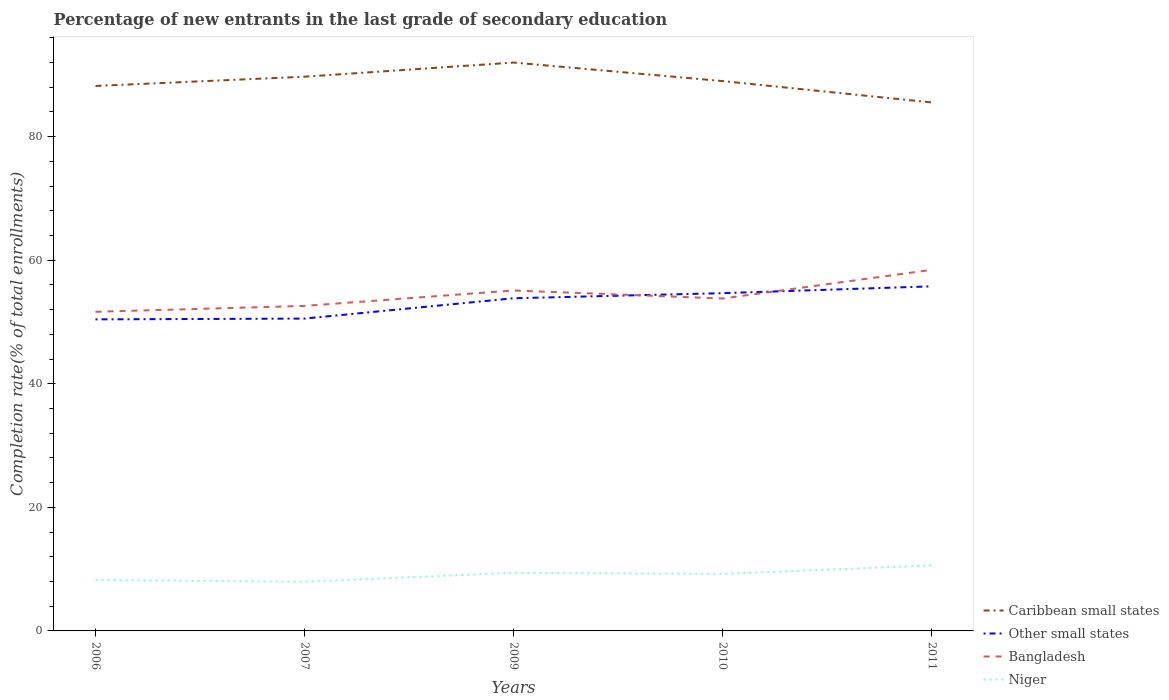Does the line corresponding to Niger intersect with the line corresponding to Caribbean small states?
Offer a very short reply. No. Across all years, what is the maximum percentage of new entrants in Other small states?
Make the answer very short. 50.43. In which year was the percentage of new entrants in Bangladesh maximum?
Provide a short and direct response. 2006. What is the total percentage of new entrants in Bangladesh in the graph?
Offer a very short reply. -4.64. What is the difference between the highest and the second highest percentage of new entrants in Bangladesh?
Offer a very short reply. 6.79. How many lines are there?
Give a very brief answer. 4. What is the difference between two consecutive major ticks on the Y-axis?
Your response must be concise. 20. Does the graph contain any zero values?
Give a very brief answer. No. How many legend labels are there?
Make the answer very short. 4. How are the legend labels stacked?
Your response must be concise. Vertical. What is the title of the graph?
Provide a succinct answer. Percentage of new entrants in the last grade of secondary education. What is the label or title of the Y-axis?
Your answer should be very brief. Completion rate(% of total enrollments). What is the Completion rate(% of total enrollments) in Caribbean small states in 2006?
Keep it short and to the point. 88.21. What is the Completion rate(% of total enrollments) of Other small states in 2006?
Offer a terse response. 50.43. What is the Completion rate(% of total enrollments) of Bangladesh in 2006?
Keep it short and to the point. 51.66. What is the Completion rate(% of total enrollments) of Niger in 2006?
Your answer should be compact. 8.24. What is the Completion rate(% of total enrollments) of Caribbean small states in 2007?
Your answer should be very brief. 89.71. What is the Completion rate(% of total enrollments) of Other small states in 2007?
Offer a terse response. 50.56. What is the Completion rate(% of total enrollments) in Bangladesh in 2007?
Your answer should be compact. 52.61. What is the Completion rate(% of total enrollments) in Niger in 2007?
Keep it short and to the point. 7.96. What is the Completion rate(% of total enrollments) in Caribbean small states in 2009?
Ensure brevity in your answer.  92. What is the Completion rate(% of total enrollments) in Other small states in 2009?
Your response must be concise. 53.85. What is the Completion rate(% of total enrollments) of Bangladesh in 2009?
Your response must be concise. 55.11. What is the Completion rate(% of total enrollments) in Niger in 2009?
Provide a short and direct response. 9.4. What is the Completion rate(% of total enrollments) in Caribbean small states in 2010?
Give a very brief answer. 89. What is the Completion rate(% of total enrollments) of Other small states in 2010?
Your answer should be compact. 54.67. What is the Completion rate(% of total enrollments) of Bangladesh in 2010?
Your answer should be very brief. 53.81. What is the Completion rate(% of total enrollments) of Niger in 2010?
Make the answer very short. 9.23. What is the Completion rate(% of total enrollments) of Caribbean small states in 2011?
Your answer should be very brief. 85.54. What is the Completion rate(% of total enrollments) in Other small states in 2011?
Offer a very short reply. 55.78. What is the Completion rate(% of total enrollments) of Bangladesh in 2011?
Provide a short and direct response. 58.45. What is the Completion rate(% of total enrollments) of Niger in 2011?
Make the answer very short. 10.6. Across all years, what is the maximum Completion rate(% of total enrollments) of Caribbean small states?
Your answer should be compact. 92. Across all years, what is the maximum Completion rate(% of total enrollments) of Other small states?
Your answer should be very brief. 55.78. Across all years, what is the maximum Completion rate(% of total enrollments) of Bangladesh?
Keep it short and to the point. 58.45. Across all years, what is the maximum Completion rate(% of total enrollments) of Niger?
Offer a very short reply. 10.6. Across all years, what is the minimum Completion rate(% of total enrollments) of Caribbean small states?
Offer a terse response. 85.54. Across all years, what is the minimum Completion rate(% of total enrollments) of Other small states?
Your answer should be very brief. 50.43. Across all years, what is the minimum Completion rate(% of total enrollments) in Bangladesh?
Provide a succinct answer. 51.66. Across all years, what is the minimum Completion rate(% of total enrollments) in Niger?
Your answer should be compact. 7.96. What is the total Completion rate(% of total enrollments) in Caribbean small states in the graph?
Ensure brevity in your answer.  444.46. What is the total Completion rate(% of total enrollments) in Other small states in the graph?
Provide a succinct answer. 265.28. What is the total Completion rate(% of total enrollments) in Bangladesh in the graph?
Make the answer very short. 271.63. What is the total Completion rate(% of total enrollments) in Niger in the graph?
Your response must be concise. 45.43. What is the difference between the Completion rate(% of total enrollments) in Caribbean small states in 2006 and that in 2007?
Offer a terse response. -1.5. What is the difference between the Completion rate(% of total enrollments) in Other small states in 2006 and that in 2007?
Ensure brevity in your answer.  -0.13. What is the difference between the Completion rate(% of total enrollments) of Bangladesh in 2006 and that in 2007?
Keep it short and to the point. -0.95. What is the difference between the Completion rate(% of total enrollments) in Niger in 2006 and that in 2007?
Provide a short and direct response. 0.28. What is the difference between the Completion rate(% of total enrollments) of Caribbean small states in 2006 and that in 2009?
Provide a short and direct response. -3.79. What is the difference between the Completion rate(% of total enrollments) in Other small states in 2006 and that in 2009?
Make the answer very short. -3.42. What is the difference between the Completion rate(% of total enrollments) of Bangladesh in 2006 and that in 2009?
Make the answer very short. -3.45. What is the difference between the Completion rate(% of total enrollments) in Niger in 2006 and that in 2009?
Your answer should be compact. -1.17. What is the difference between the Completion rate(% of total enrollments) in Caribbean small states in 2006 and that in 2010?
Offer a very short reply. -0.79. What is the difference between the Completion rate(% of total enrollments) of Other small states in 2006 and that in 2010?
Your answer should be compact. -4.24. What is the difference between the Completion rate(% of total enrollments) of Bangladesh in 2006 and that in 2010?
Give a very brief answer. -2.15. What is the difference between the Completion rate(% of total enrollments) of Niger in 2006 and that in 2010?
Make the answer very short. -0.99. What is the difference between the Completion rate(% of total enrollments) of Caribbean small states in 2006 and that in 2011?
Provide a succinct answer. 2.67. What is the difference between the Completion rate(% of total enrollments) in Other small states in 2006 and that in 2011?
Ensure brevity in your answer.  -5.35. What is the difference between the Completion rate(% of total enrollments) of Bangladesh in 2006 and that in 2011?
Offer a very short reply. -6.79. What is the difference between the Completion rate(% of total enrollments) in Niger in 2006 and that in 2011?
Keep it short and to the point. -2.36. What is the difference between the Completion rate(% of total enrollments) of Caribbean small states in 2007 and that in 2009?
Provide a succinct answer. -2.29. What is the difference between the Completion rate(% of total enrollments) in Other small states in 2007 and that in 2009?
Your response must be concise. -3.29. What is the difference between the Completion rate(% of total enrollments) of Bangladesh in 2007 and that in 2009?
Offer a terse response. -2.5. What is the difference between the Completion rate(% of total enrollments) of Niger in 2007 and that in 2009?
Provide a succinct answer. -1.44. What is the difference between the Completion rate(% of total enrollments) of Caribbean small states in 2007 and that in 2010?
Provide a succinct answer. 0.71. What is the difference between the Completion rate(% of total enrollments) of Other small states in 2007 and that in 2010?
Ensure brevity in your answer.  -4.11. What is the difference between the Completion rate(% of total enrollments) of Bangladesh in 2007 and that in 2010?
Your answer should be compact. -1.2. What is the difference between the Completion rate(% of total enrollments) of Niger in 2007 and that in 2010?
Offer a terse response. -1.27. What is the difference between the Completion rate(% of total enrollments) of Caribbean small states in 2007 and that in 2011?
Provide a short and direct response. 4.17. What is the difference between the Completion rate(% of total enrollments) in Other small states in 2007 and that in 2011?
Provide a succinct answer. -5.22. What is the difference between the Completion rate(% of total enrollments) in Bangladesh in 2007 and that in 2011?
Give a very brief answer. -5.84. What is the difference between the Completion rate(% of total enrollments) in Niger in 2007 and that in 2011?
Your response must be concise. -2.64. What is the difference between the Completion rate(% of total enrollments) in Caribbean small states in 2009 and that in 2010?
Give a very brief answer. 3. What is the difference between the Completion rate(% of total enrollments) of Other small states in 2009 and that in 2010?
Ensure brevity in your answer.  -0.82. What is the difference between the Completion rate(% of total enrollments) of Bangladesh in 2009 and that in 2010?
Your response must be concise. 1.3. What is the difference between the Completion rate(% of total enrollments) in Niger in 2009 and that in 2010?
Make the answer very short. 0.18. What is the difference between the Completion rate(% of total enrollments) of Caribbean small states in 2009 and that in 2011?
Keep it short and to the point. 6.46. What is the difference between the Completion rate(% of total enrollments) of Other small states in 2009 and that in 2011?
Give a very brief answer. -1.93. What is the difference between the Completion rate(% of total enrollments) in Bangladesh in 2009 and that in 2011?
Your answer should be very brief. -3.34. What is the difference between the Completion rate(% of total enrollments) in Niger in 2009 and that in 2011?
Offer a terse response. -1.2. What is the difference between the Completion rate(% of total enrollments) of Caribbean small states in 2010 and that in 2011?
Give a very brief answer. 3.46. What is the difference between the Completion rate(% of total enrollments) of Other small states in 2010 and that in 2011?
Provide a short and direct response. -1.11. What is the difference between the Completion rate(% of total enrollments) in Bangladesh in 2010 and that in 2011?
Offer a terse response. -4.64. What is the difference between the Completion rate(% of total enrollments) in Niger in 2010 and that in 2011?
Give a very brief answer. -1.37. What is the difference between the Completion rate(% of total enrollments) of Caribbean small states in 2006 and the Completion rate(% of total enrollments) of Other small states in 2007?
Your answer should be compact. 37.65. What is the difference between the Completion rate(% of total enrollments) in Caribbean small states in 2006 and the Completion rate(% of total enrollments) in Bangladesh in 2007?
Your response must be concise. 35.6. What is the difference between the Completion rate(% of total enrollments) in Caribbean small states in 2006 and the Completion rate(% of total enrollments) in Niger in 2007?
Provide a succinct answer. 80.25. What is the difference between the Completion rate(% of total enrollments) of Other small states in 2006 and the Completion rate(% of total enrollments) of Bangladesh in 2007?
Offer a terse response. -2.18. What is the difference between the Completion rate(% of total enrollments) in Other small states in 2006 and the Completion rate(% of total enrollments) in Niger in 2007?
Your answer should be very brief. 42.47. What is the difference between the Completion rate(% of total enrollments) of Bangladesh in 2006 and the Completion rate(% of total enrollments) of Niger in 2007?
Offer a terse response. 43.69. What is the difference between the Completion rate(% of total enrollments) of Caribbean small states in 2006 and the Completion rate(% of total enrollments) of Other small states in 2009?
Offer a very short reply. 34.36. What is the difference between the Completion rate(% of total enrollments) in Caribbean small states in 2006 and the Completion rate(% of total enrollments) in Bangladesh in 2009?
Provide a short and direct response. 33.1. What is the difference between the Completion rate(% of total enrollments) of Caribbean small states in 2006 and the Completion rate(% of total enrollments) of Niger in 2009?
Your answer should be compact. 78.81. What is the difference between the Completion rate(% of total enrollments) in Other small states in 2006 and the Completion rate(% of total enrollments) in Bangladesh in 2009?
Provide a succinct answer. -4.68. What is the difference between the Completion rate(% of total enrollments) in Other small states in 2006 and the Completion rate(% of total enrollments) in Niger in 2009?
Make the answer very short. 41.02. What is the difference between the Completion rate(% of total enrollments) of Bangladesh in 2006 and the Completion rate(% of total enrollments) of Niger in 2009?
Offer a very short reply. 42.25. What is the difference between the Completion rate(% of total enrollments) in Caribbean small states in 2006 and the Completion rate(% of total enrollments) in Other small states in 2010?
Your answer should be compact. 33.54. What is the difference between the Completion rate(% of total enrollments) in Caribbean small states in 2006 and the Completion rate(% of total enrollments) in Bangladesh in 2010?
Your answer should be compact. 34.4. What is the difference between the Completion rate(% of total enrollments) of Caribbean small states in 2006 and the Completion rate(% of total enrollments) of Niger in 2010?
Provide a short and direct response. 78.98. What is the difference between the Completion rate(% of total enrollments) of Other small states in 2006 and the Completion rate(% of total enrollments) of Bangladesh in 2010?
Keep it short and to the point. -3.38. What is the difference between the Completion rate(% of total enrollments) of Other small states in 2006 and the Completion rate(% of total enrollments) of Niger in 2010?
Provide a succinct answer. 41.2. What is the difference between the Completion rate(% of total enrollments) in Bangladesh in 2006 and the Completion rate(% of total enrollments) in Niger in 2010?
Give a very brief answer. 42.43. What is the difference between the Completion rate(% of total enrollments) in Caribbean small states in 2006 and the Completion rate(% of total enrollments) in Other small states in 2011?
Give a very brief answer. 32.43. What is the difference between the Completion rate(% of total enrollments) in Caribbean small states in 2006 and the Completion rate(% of total enrollments) in Bangladesh in 2011?
Your response must be concise. 29.76. What is the difference between the Completion rate(% of total enrollments) in Caribbean small states in 2006 and the Completion rate(% of total enrollments) in Niger in 2011?
Your answer should be compact. 77.61. What is the difference between the Completion rate(% of total enrollments) of Other small states in 2006 and the Completion rate(% of total enrollments) of Bangladesh in 2011?
Provide a short and direct response. -8.02. What is the difference between the Completion rate(% of total enrollments) in Other small states in 2006 and the Completion rate(% of total enrollments) in Niger in 2011?
Ensure brevity in your answer.  39.83. What is the difference between the Completion rate(% of total enrollments) of Bangladesh in 2006 and the Completion rate(% of total enrollments) of Niger in 2011?
Provide a succinct answer. 41.05. What is the difference between the Completion rate(% of total enrollments) of Caribbean small states in 2007 and the Completion rate(% of total enrollments) of Other small states in 2009?
Give a very brief answer. 35.86. What is the difference between the Completion rate(% of total enrollments) in Caribbean small states in 2007 and the Completion rate(% of total enrollments) in Bangladesh in 2009?
Your response must be concise. 34.6. What is the difference between the Completion rate(% of total enrollments) in Caribbean small states in 2007 and the Completion rate(% of total enrollments) in Niger in 2009?
Provide a succinct answer. 80.31. What is the difference between the Completion rate(% of total enrollments) in Other small states in 2007 and the Completion rate(% of total enrollments) in Bangladesh in 2009?
Make the answer very short. -4.55. What is the difference between the Completion rate(% of total enrollments) of Other small states in 2007 and the Completion rate(% of total enrollments) of Niger in 2009?
Give a very brief answer. 41.15. What is the difference between the Completion rate(% of total enrollments) in Bangladesh in 2007 and the Completion rate(% of total enrollments) in Niger in 2009?
Provide a short and direct response. 43.2. What is the difference between the Completion rate(% of total enrollments) of Caribbean small states in 2007 and the Completion rate(% of total enrollments) of Other small states in 2010?
Offer a very short reply. 35.04. What is the difference between the Completion rate(% of total enrollments) of Caribbean small states in 2007 and the Completion rate(% of total enrollments) of Bangladesh in 2010?
Provide a short and direct response. 35.9. What is the difference between the Completion rate(% of total enrollments) in Caribbean small states in 2007 and the Completion rate(% of total enrollments) in Niger in 2010?
Provide a succinct answer. 80.48. What is the difference between the Completion rate(% of total enrollments) in Other small states in 2007 and the Completion rate(% of total enrollments) in Bangladesh in 2010?
Keep it short and to the point. -3.25. What is the difference between the Completion rate(% of total enrollments) in Other small states in 2007 and the Completion rate(% of total enrollments) in Niger in 2010?
Your answer should be very brief. 41.33. What is the difference between the Completion rate(% of total enrollments) of Bangladesh in 2007 and the Completion rate(% of total enrollments) of Niger in 2010?
Keep it short and to the point. 43.38. What is the difference between the Completion rate(% of total enrollments) of Caribbean small states in 2007 and the Completion rate(% of total enrollments) of Other small states in 2011?
Keep it short and to the point. 33.93. What is the difference between the Completion rate(% of total enrollments) of Caribbean small states in 2007 and the Completion rate(% of total enrollments) of Bangladesh in 2011?
Your answer should be compact. 31.26. What is the difference between the Completion rate(% of total enrollments) in Caribbean small states in 2007 and the Completion rate(% of total enrollments) in Niger in 2011?
Make the answer very short. 79.11. What is the difference between the Completion rate(% of total enrollments) of Other small states in 2007 and the Completion rate(% of total enrollments) of Bangladesh in 2011?
Offer a terse response. -7.89. What is the difference between the Completion rate(% of total enrollments) of Other small states in 2007 and the Completion rate(% of total enrollments) of Niger in 2011?
Offer a very short reply. 39.96. What is the difference between the Completion rate(% of total enrollments) in Bangladesh in 2007 and the Completion rate(% of total enrollments) in Niger in 2011?
Offer a terse response. 42.01. What is the difference between the Completion rate(% of total enrollments) in Caribbean small states in 2009 and the Completion rate(% of total enrollments) in Other small states in 2010?
Offer a terse response. 37.33. What is the difference between the Completion rate(% of total enrollments) of Caribbean small states in 2009 and the Completion rate(% of total enrollments) of Bangladesh in 2010?
Give a very brief answer. 38.2. What is the difference between the Completion rate(% of total enrollments) of Caribbean small states in 2009 and the Completion rate(% of total enrollments) of Niger in 2010?
Keep it short and to the point. 82.78. What is the difference between the Completion rate(% of total enrollments) in Other small states in 2009 and the Completion rate(% of total enrollments) in Bangladesh in 2010?
Your answer should be very brief. 0.04. What is the difference between the Completion rate(% of total enrollments) of Other small states in 2009 and the Completion rate(% of total enrollments) of Niger in 2010?
Make the answer very short. 44.62. What is the difference between the Completion rate(% of total enrollments) of Bangladesh in 2009 and the Completion rate(% of total enrollments) of Niger in 2010?
Your response must be concise. 45.88. What is the difference between the Completion rate(% of total enrollments) of Caribbean small states in 2009 and the Completion rate(% of total enrollments) of Other small states in 2011?
Your response must be concise. 36.22. What is the difference between the Completion rate(% of total enrollments) in Caribbean small states in 2009 and the Completion rate(% of total enrollments) in Bangladesh in 2011?
Offer a very short reply. 33.55. What is the difference between the Completion rate(% of total enrollments) of Caribbean small states in 2009 and the Completion rate(% of total enrollments) of Niger in 2011?
Give a very brief answer. 81.4. What is the difference between the Completion rate(% of total enrollments) of Other small states in 2009 and the Completion rate(% of total enrollments) of Bangladesh in 2011?
Provide a short and direct response. -4.6. What is the difference between the Completion rate(% of total enrollments) in Other small states in 2009 and the Completion rate(% of total enrollments) in Niger in 2011?
Offer a very short reply. 43.25. What is the difference between the Completion rate(% of total enrollments) in Bangladesh in 2009 and the Completion rate(% of total enrollments) in Niger in 2011?
Your response must be concise. 44.51. What is the difference between the Completion rate(% of total enrollments) of Caribbean small states in 2010 and the Completion rate(% of total enrollments) of Other small states in 2011?
Your response must be concise. 33.22. What is the difference between the Completion rate(% of total enrollments) of Caribbean small states in 2010 and the Completion rate(% of total enrollments) of Bangladesh in 2011?
Your answer should be compact. 30.55. What is the difference between the Completion rate(% of total enrollments) of Caribbean small states in 2010 and the Completion rate(% of total enrollments) of Niger in 2011?
Provide a succinct answer. 78.4. What is the difference between the Completion rate(% of total enrollments) in Other small states in 2010 and the Completion rate(% of total enrollments) in Bangladesh in 2011?
Keep it short and to the point. -3.78. What is the difference between the Completion rate(% of total enrollments) in Other small states in 2010 and the Completion rate(% of total enrollments) in Niger in 2011?
Provide a succinct answer. 44.07. What is the difference between the Completion rate(% of total enrollments) of Bangladesh in 2010 and the Completion rate(% of total enrollments) of Niger in 2011?
Offer a terse response. 43.2. What is the average Completion rate(% of total enrollments) in Caribbean small states per year?
Ensure brevity in your answer.  88.89. What is the average Completion rate(% of total enrollments) in Other small states per year?
Make the answer very short. 53.06. What is the average Completion rate(% of total enrollments) in Bangladesh per year?
Make the answer very short. 54.33. What is the average Completion rate(% of total enrollments) in Niger per year?
Make the answer very short. 9.09. In the year 2006, what is the difference between the Completion rate(% of total enrollments) in Caribbean small states and Completion rate(% of total enrollments) in Other small states?
Provide a short and direct response. 37.78. In the year 2006, what is the difference between the Completion rate(% of total enrollments) in Caribbean small states and Completion rate(% of total enrollments) in Bangladesh?
Offer a very short reply. 36.55. In the year 2006, what is the difference between the Completion rate(% of total enrollments) of Caribbean small states and Completion rate(% of total enrollments) of Niger?
Offer a terse response. 79.97. In the year 2006, what is the difference between the Completion rate(% of total enrollments) in Other small states and Completion rate(% of total enrollments) in Bangladesh?
Offer a very short reply. -1.23. In the year 2006, what is the difference between the Completion rate(% of total enrollments) in Other small states and Completion rate(% of total enrollments) in Niger?
Give a very brief answer. 42.19. In the year 2006, what is the difference between the Completion rate(% of total enrollments) of Bangladesh and Completion rate(% of total enrollments) of Niger?
Ensure brevity in your answer.  43.42. In the year 2007, what is the difference between the Completion rate(% of total enrollments) in Caribbean small states and Completion rate(% of total enrollments) in Other small states?
Your response must be concise. 39.15. In the year 2007, what is the difference between the Completion rate(% of total enrollments) of Caribbean small states and Completion rate(% of total enrollments) of Bangladesh?
Provide a short and direct response. 37.1. In the year 2007, what is the difference between the Completion rate(% of total enrollments) in Caribbean small states and Completion rate(% of total enrollments) in Niger?
Ensure brevity in your answer.  81.75. In the year 2007, what is the difference between the Completion rate(% of total enrollments) of Other small states and Completion rate(% of total enrollments) of Bangladesh?
Give a very brief answer. -2.05. In the year 2007, what is the difference between the Completion rate(% of total enrollments) of Other small states and Completion rate(% of total enrollments) of Niger?
Offer a terse response. 42.6. In the year 2007, what is the difference between the Completion rate(% of total enrollments) of Bangladesh and Completion rate(% of total enrollments) of Niger?
Your answer should be very brief. 44.65. In the year 2009, what is the difference between the Completion rate(% of total enrollments) of Caribbean small states and Completion rate(% of total enrollments) of Other small states?
Your response must be concise. 38.16. In the year 2009, what is the difference between the Completion rate(% of total enrollments) in Caribbean small states and Completion rate(% of total enrollments) in Bangladesh?
Offer a very short reply. 36.89. In the year 2009, what is the difference between the Completion rate(% of total enrollments) in Caribbean small states and Completion rate(% of total enrollments) in Niger?
Give a very brief answer. 82.6. In the year 2009, what is the difference between the Completion rate(% of total enrollments) of Other small states and Completion rate(% of total enrollments) of Bangladesh?
Your response must be concise. -1.26. In the year 2009, what is the difference between the Completion rate(% of total enrollments) in Other small states and Completion rate(% of total enrollments) in Niger?
Offer a terse response. 44.44. In the year 2009, what is the difference between the Completion rate(% of total enrollments) of Bangladesh and Completion rate(% of total enrollments) of Niger?
Offer a very short reply. 45.7. In the year 2010, what is the difference between the Completion rate(% of total enrollments) in Caribbean small states and Completion rate(% of total enrollments) in Other small states?
Make the answer very short. 34.33. In the year 2010, what is the difference between the Completion rate(% of total enrollments) of Caribbean small states and Completion rate(% of total enrollments) of Bangladesh?
Keep it short and to the point. 35.19. In the year 2010, what is the difference between the Completion rate(% of total enrollments) of Caribbean small states and Completion rate(% of total enrollments) of Niger?
Your response must be concise. 79.77. In the year 2010, what is the difference between the Completion rate(% of total enrollments) in Other small states and Completion rate(% of total enrollments) in Bangladesh?
Your answer should be compact. 0.87. In the year 2010, what is the difference between the Completion rate(% of total enrollments) in Other small states and Completion rate(% of total enrollments) in Niger?
Offer a terse response. 45.44. In the year 2010, what is the difference between the Completion rate(% of total enrollments) of Bangladesh and Completion rate(% of total enrollments) of Niger?
Keep it short and to the point. 44.58. In the year 2011, what is the difference between the Completion rate(% of total enrollments) in Caribbean small states and Completion rate(% of total enrollments) in Other small states?
Offer a very short reply. 29.76. In the year 2011, what is the difference between the Completion rate(% of total enrollments) of Caribbean small states and Completion rate(% of total enrollments) of Bangladesh?
Keep it short and to the point. 27.09. In the year 2011, what is the difference between the Completion rate(% of total enrollments) of Caribbean small states and Completion rate(% of total enrollments) of Niger?
Keep it short and to the point. 74.94. In the year 2011, what is the difference between the Completion rate(% of total enrollments) of Other small states and Completion rate(% of total enrollments) of Bangladesh?
Your response must be concise. -2.67. In the year 2011, what is the difference between the Completion rate(% of total enrollments) in Other small states and Completion rate(% of total enrollments) in Niger?
Provide a short and direct response. 45.18. In the year 2011, what is the difference between the Completion rate(% of total enrollments) of Bangladesh and Completion rate(% of total enrollments) of Niger?
Offer a very short reply. 47.85. What is the ratio of the Completion rate(% of total enrollments) in Caribbean small states in 2006 to that in 2007?
Your answer should be very brief. 0.98. What is the ratio of the Completion rate(% of total enrollments) of Other small states in 2006 to that in 2007?
Your answer should be very brief. 1. What is the ratio of the Completion rate(% of total enrollments) of Bangladesh in 2006 to that in 2007?
Ensure brevity in your answer.  0.98. What is the ratio of the Completion rate(% of total enrollments) of Niger in 2006 to that in 2007?
Keep it short and to the point. 1.03. What is the ratio of the Completion rate(% of total enrollments) in Caribbean small states in 2006 to that in 2009?
Your answer should be very brief. 0.96. What is the ratio of the Completion rate(% of total enrollments) in Other small states in 2006 to that in 2009?
Ensure brevity in your answer.  0.94. What is the ratio of the Completion rate(% of total enrollments) in Bangladesh in 2006 to that in 2009?
Give a very brief answer. 0.94. What is the ratio of the Completion rate(% of total enrollments) in Niger in 2006 to that in 2009?
Offer a terse response. 0.88. What is the ratio of the Completion rate(% of total enrollments) in Caribbean small states in 2006 to that in 2010?
Ensure brevity in your answer.  0.99. What is the ratio of the Completion rate(% of total enrollments) in Other small states in 2006 to that in 2010?
Offer a terse response. 0.92. What is the ratio of the Completion rate(% of total enrollments) in Niger in 2006 to that in 2010?
Make the answer very short. 0.89. What is the ratio of the Completion rate(% of total enrollments) of Caribbean small states in 2006 to that in 2011?
Offer a very short reply. 1.03. What is the ratio of the Completion rate(% of total enrollments) in Other small states in 2006 to that in 2011?
Ensure brevity in your answer.  0.9. What is the ratio of the Completion rate(% of total enrollments) in Bangladesh in 2006 to that in 2011?
Offer a very short reply. 0.88. What is the ratio of the Completion rate(% of total enrollments) in Niger in 2006 to that in 2011?
Provide a succinct answer. 0.78. What is the ratio of the Completion rate(% of total enrollments) in Caribbean small states in 2007 to that in 2009?
Your answer should be very brief. 0.98. What is the ratio of the Completion rate(% of total enrollments) of Other small states in 2007 to that in 2009?
Offer a terse response. 0.94. What is the ratio of the Completion rate(% of total enrollments) in Bangladesh in 2007 to that in 2009?
Give a very brief answer. 0.95. What is the ratio of the Completion rate(% of total enrollments) of Niger in 2007 to that in 2009?
Offer a terse response. 0.85. What is the ratio of the Completion rate(% of total enrollments) of Caribbean small states in 2007 to that in 2010?
Provide a short and direct response. 1.01. What is the ratio of the Completion rate(% of total enrollments) of Other small states in 2007 to that in 2010?
Your answer should be compact. 0.92. What is the ratio of the Completion rate(% of total enrollments) in Bangladesh in 2007 to that in 2010?
Keep it short and to the point. 0.98. What is the ratio of the Completion rate(% of total enrollments) of Niger in 2007 to that in 2010?
Provide a short and direct response. 0.86. What is the ratio of the Completion rate(% of total enrollments) in Caribbean small states in 2007 to that in 2011?
Provide a succinct answer. 1.05. What is the ratio of the Completion rate(% of total enrollments) in Other small states in 2007 to that in 2011?
Keep it short and to the point. 0.91. What is the ratio of the Completion rate(% of total enrollments) of Bangladesh in 2007 to that in 2011?
Make the answer very short. 0.9. What is the ratio of the Completion rate(% of total enrollments) of Niger in 2007 to that in 2011?
Your answer should be compact. 0.75. What is the ratio of the Completion rate(% of total enrollments) in Caribbean small states in 2009 to that in 2010?
Make the answer very short. 1.03. What is the ratio of the Completion rate(% of total enrollments) in Other small states in 2009 to that in 2010?
Provide a short and direct response. 0.98. What is the ratio of the Completion rate(% of total enrollments) of Bangladesh in 2009 to that in 2010?
Keep it short and to the point. 1.02. What is the ratio of the Completion rate(% of total enrollments) in Niger in 2009 to that in 2010?
Offer a very short reply. 1.02. What is the ratio of the Completion rate(% of total enrollments) in Caribbean small states in 2009 to that in 2011?
Provide a short and direct response. 1.08. What is the ratio of the Completion rate(% of total enrollments) in Other small states in 2009 to that in 2011?
Make the answer very short. 0.97. What is the ratio of the Completion rate(% of total enrollments) of Bangladesh in 2009 to that in 2011?
Ensure brevity in your answer.  0.94. What is the ratio of the Completion rate(% of total enrollments) in Niger in 2009 to that in 2011?
Offer a terse response. 0.89. What is the ratio of the Completion rate(% of total enrollments) in Caribbean small states in 2010 to that in 2011?
Your response must be concise. 1.04. What is the ratio of the Completion rate(% of total enrollments) in Other small states in 2010 to that in 2011?
Give a very brief answer. 0.98. What is the ratio of the Completion rate(% of total enrollments) in Bangladesh in 2010 to that in 2011?
Your answer should be very brief. 0.92. What is the ratio of the Completion rate(% of total enrollments) of Niger in 2010 to that in 2011?
Provide a short and direct response. 0.87. What is the difference between the highest and the second highest Completion rate(% of total enrollments) in Caribbean small states?
Give a very brief answer. 2.29. What is the difference between the highest and the second highest Completion rate(% of total enrollments) of Other small states?
Provide a succinct answer. 1.11. What is the difference between the highest and the second highest Completion rate(% of total enrollments) of Bangladesh?
Provide a succinct answer. 3.34. What is the difference between the highest and the second highest Completion rate(% of total enrollments) of Niger?
Offer a terse response. 1.2. What is the difference between the highest and the lowest Completion rate(% of total enrollments) of Caribbean small states?
Your response must be concise. 6.46. What is the difference between the highest and the lowest Completion rate(% of total enrollments) in Other small states?
Keep it short and to the point. 5.35. What is the difference between the highest and the lowest Completion rate(% of total enrollments) in Bangladesh?
Keep it short and to the point. 6.79. What is the difference between the highest and the lowest Completion rate(% of total enrollments) in Niger?
Provide a short and direct response. 2.64. 